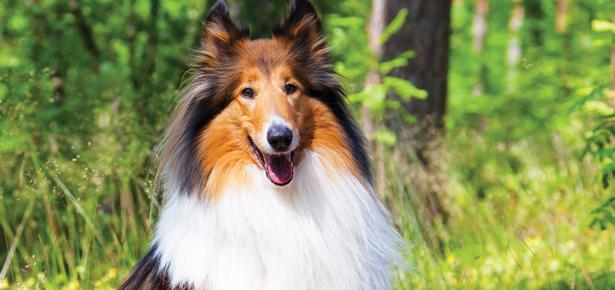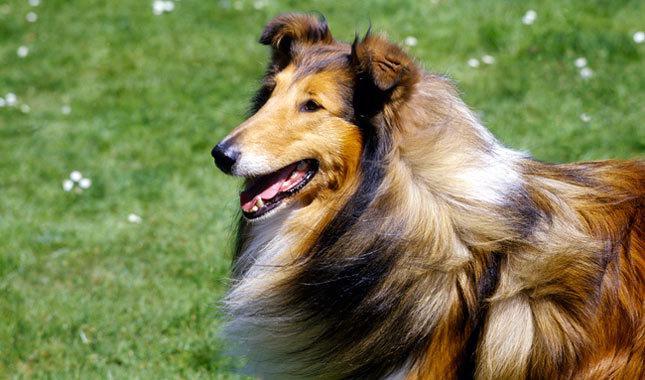The first image is the image on the left, the second image is the image on the right. Examine the images to the left and right. Is the description "The dog in the image on the left is looking toward the camera." accurate? Answer yes or no. Yes. 